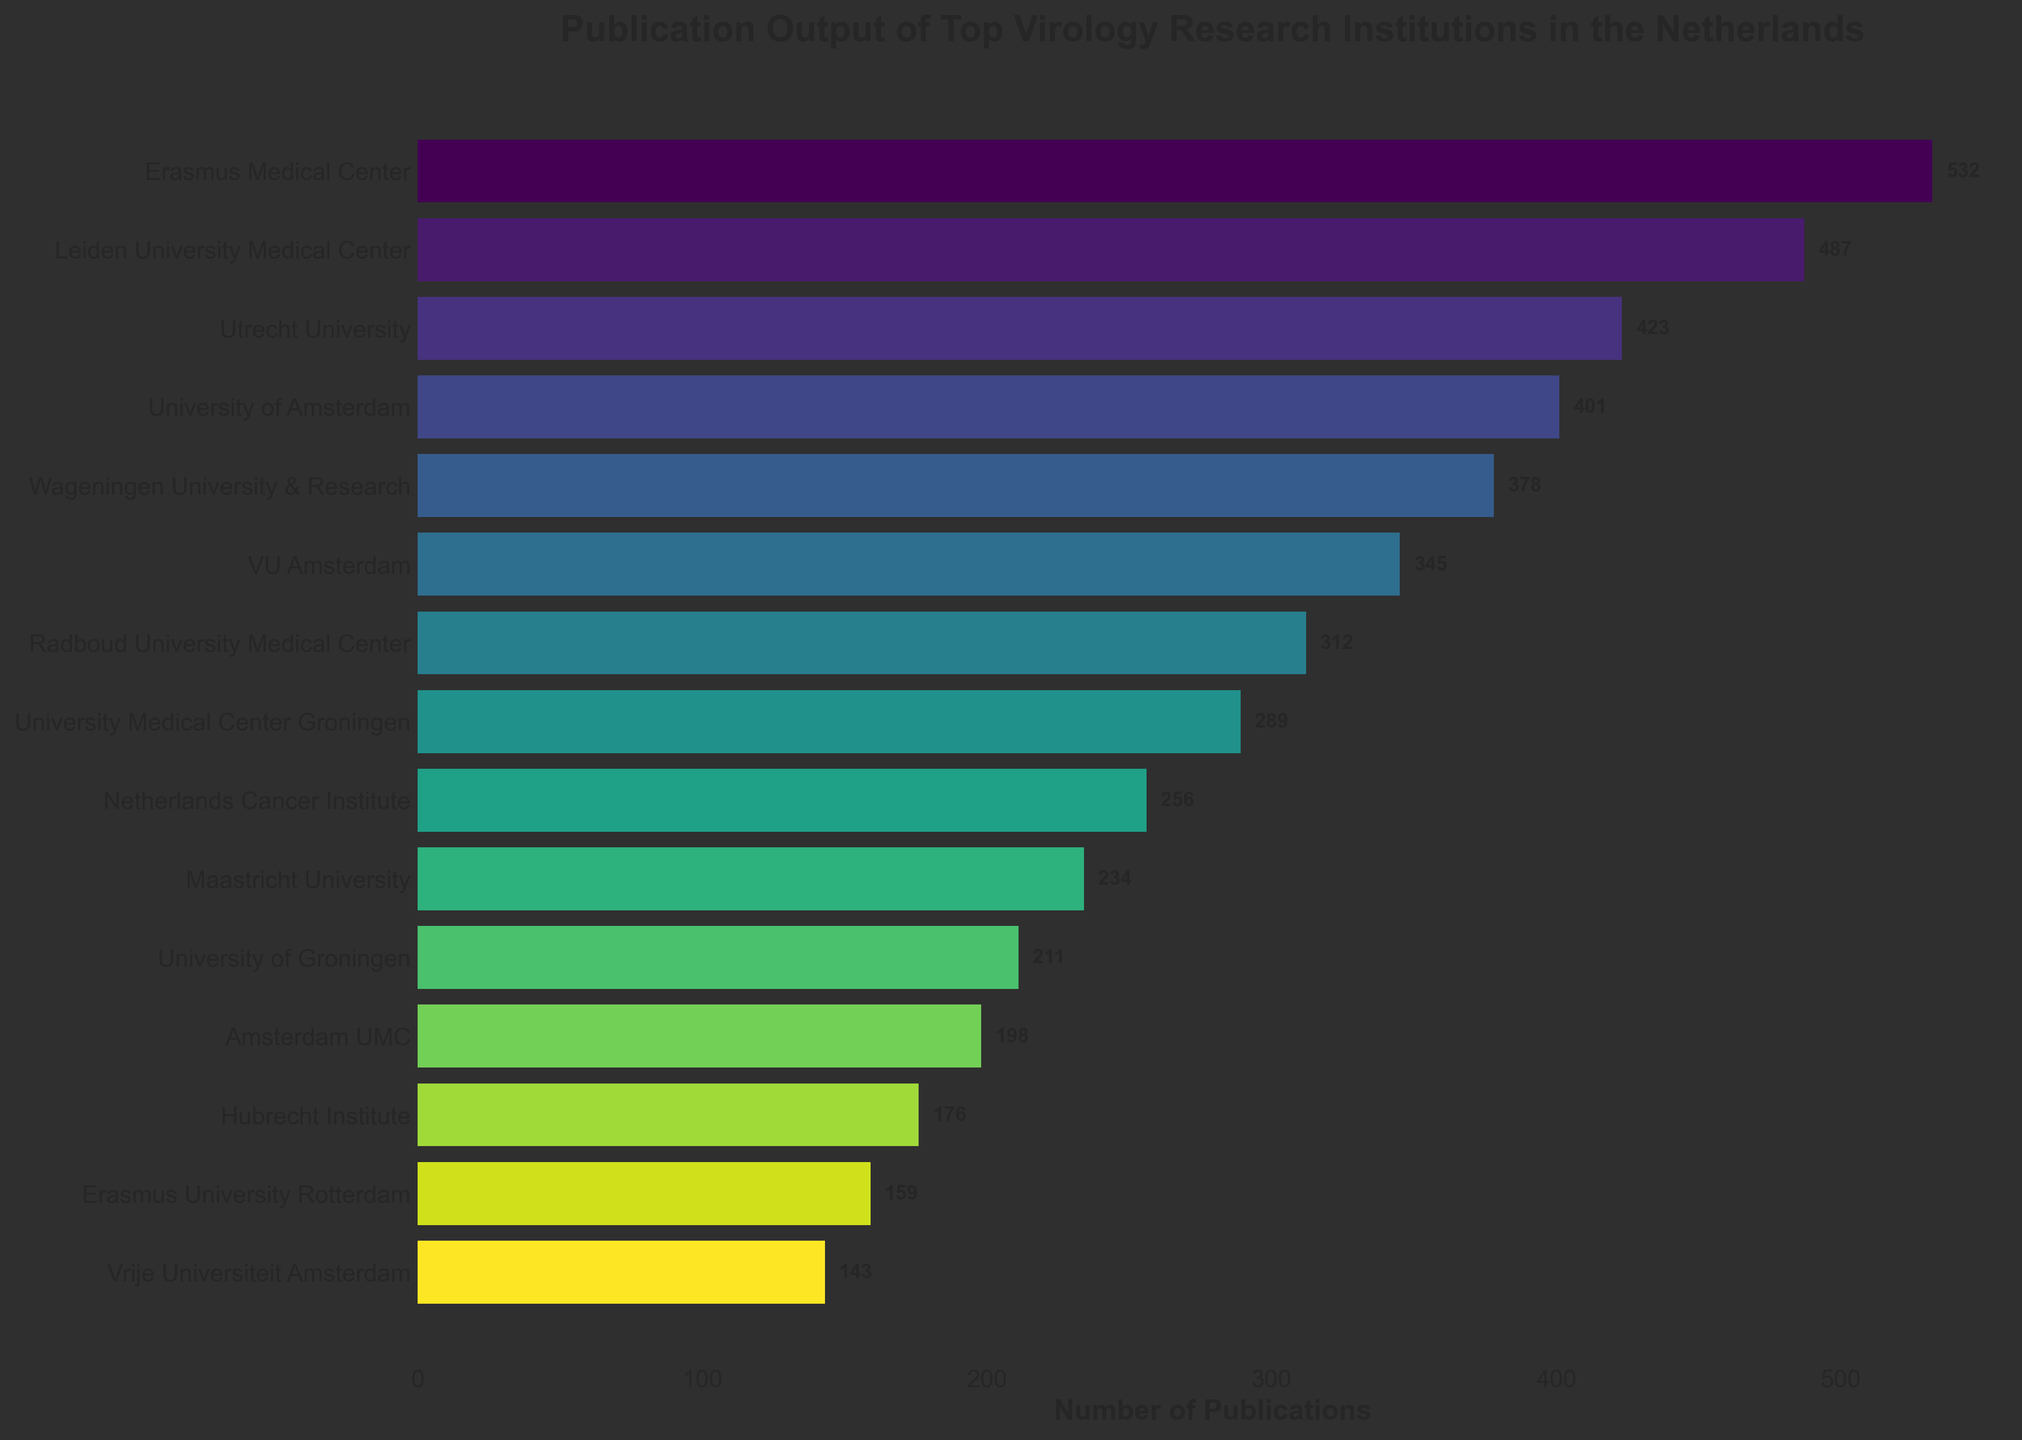Which institution has the highest number of publications? By inspecting the bar chart, the bar corresponding to the Erasmus Medical Center is the longest, indicating the highest number of publications.
Answer: Erasmus Medical Center What is the total number of publications for the top three institutions? Summing the publication counts of the top three institutions:
532 (Erasmus Medical Center) + 487 (Leiden University Medical Center) + 423 (Utrecht University) = 1442
Answer: 1442 Which institution has fewer publications: the University of Amsterdam or VU Amsterdam? By comparing the lengths of the bars for the University of Amsterdam (401 publications) and VU Amsterdam (345 publications), we see that VU Amsterdam has fewer publications.
Answer: VU Amsterdam What is the average number of publications for the top five institutions? Summing the publications of the top five institutions and dividing by five:
(532 + 487 + 423 + 401 + 378) / 5 = 2221 / 5 ≈ 444.2
Answer: 444.2 How much more does Amsterdam UMC need to surpass Maastricht University? The difference in publications between Maastricht University (234) and Amsterdam UMC (198) is 234 - 198 = 36. Amsterdam UMC needs 37 more publications to surpass Maastricht University.
Answer: 37 Which institutions have an equal number of publications? By visually inspecting the bars, there is no pair of institutions with equal publication counts.
Answer: None What is the combined publication output of the bottom three institutions? Summing the publication counts of the three institutions with the smallest outputs:
198 (Amsterdam UMC) + 176 (Hubrecht Institute) + 159 (Erasmus University Rotterdam) = 533
Answer: 533 How many more publications does the Erasmus Medical Center have compared to the University of Amsterdam? The difference in publications is 532 (Erasmus Medical Center) - 401 (University of Amsterdam) = 131.
Answer: 131 Which institution ranks at the middle in terms of publication output? With 15 institutions listed, the middle institution would be the 8th. Sorting by the number of publications, the University Medical Center Groningen, with 289 publications, ranks in the middle.
Answer: University Medical Center Groningen What percentage of the total publications is contributed by the Erasmus Medical Center? First calculate the total number of publications, then find the percentage contribution of the Erasmus Medical Center.
Total publications = 532 + 487 + 423 + 401 + 378 + 345 + 312 + 289 + 256 + 234 + 211 + 198 + 176 + 159 + 143 = 4544
Percentage = (532 / 4544) * 100 ≈ 11.71%
Answer: 11.71% 